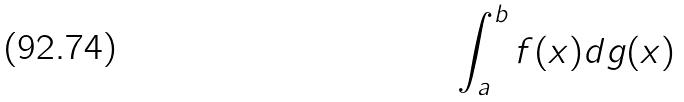<formula> <loc_0><loc_0><loc_500><loc_500>\int _ { a } ^ { b } f ( x ) d g ( x )</formula> 